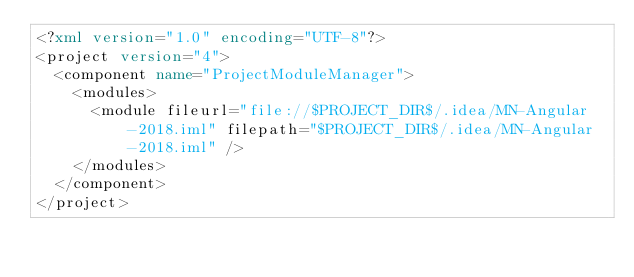<code> <loc_0><loc_0><loc_500><loc_500><_XML_><?xml version="1.0" encoding="UTF-8"?>
<project version="4">
  <component name="ProjectModuleManager">
    <modules>
      <module fileurl="file://$PROJECT_DIR$/.idea/MN-Angular-2018.iml" filepath="$PROJECT_DIR$/.idea/MN-Angular-2018.iml" />
    </modules>
  </component>
</project></code> 